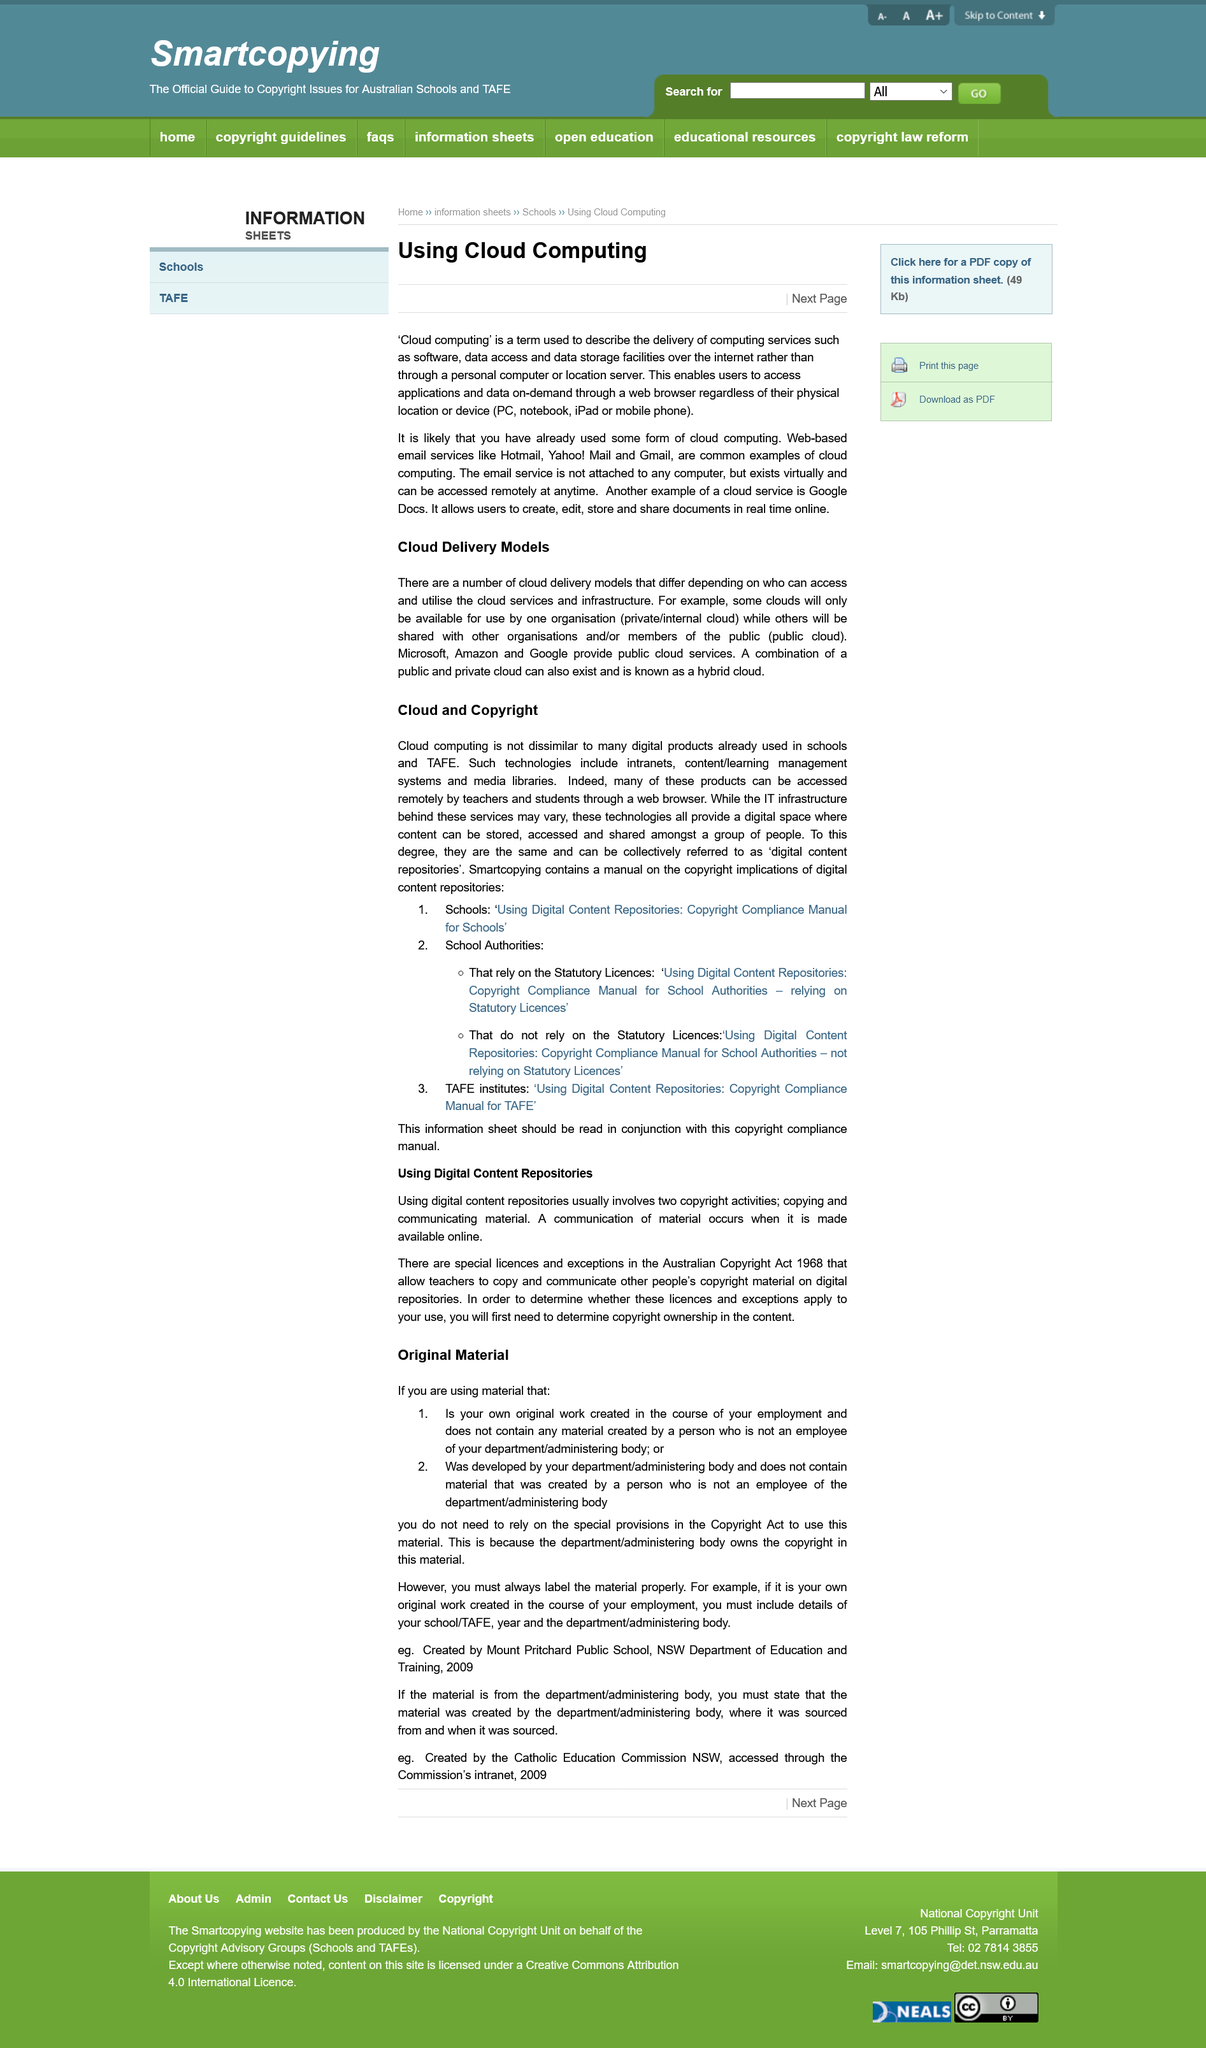Identify some key points in this picture. Using digital repositories typically requires two copyright-related activities. A hybrid cloud is a combination of a public and private cloud, characterized by the integration of a private cloud environment with a public cloud environment to leverage the strengths of each system while addressing the limitations of either alone. In a hybrid cloud, data and applications can be shared and accessed across multiple cloud environments, enabling organizations to take advantage of the benefits of both cloud models while maintaining control over sensitive data and applications. These technologies offer a digital space wherein content can be stored, accessed, and shared amongst a group of people, thereby facilitating efficient and convenient collaboration. This page is about the purpose of using digital content repositories. SmartCopying contains a manual on the copyright implications of digital content repositories. 